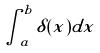<formula> <loc_0><loc_0><loc_500><loc_500>\int _ { a } ^ { b } \delta ( x ) d x</formula> 